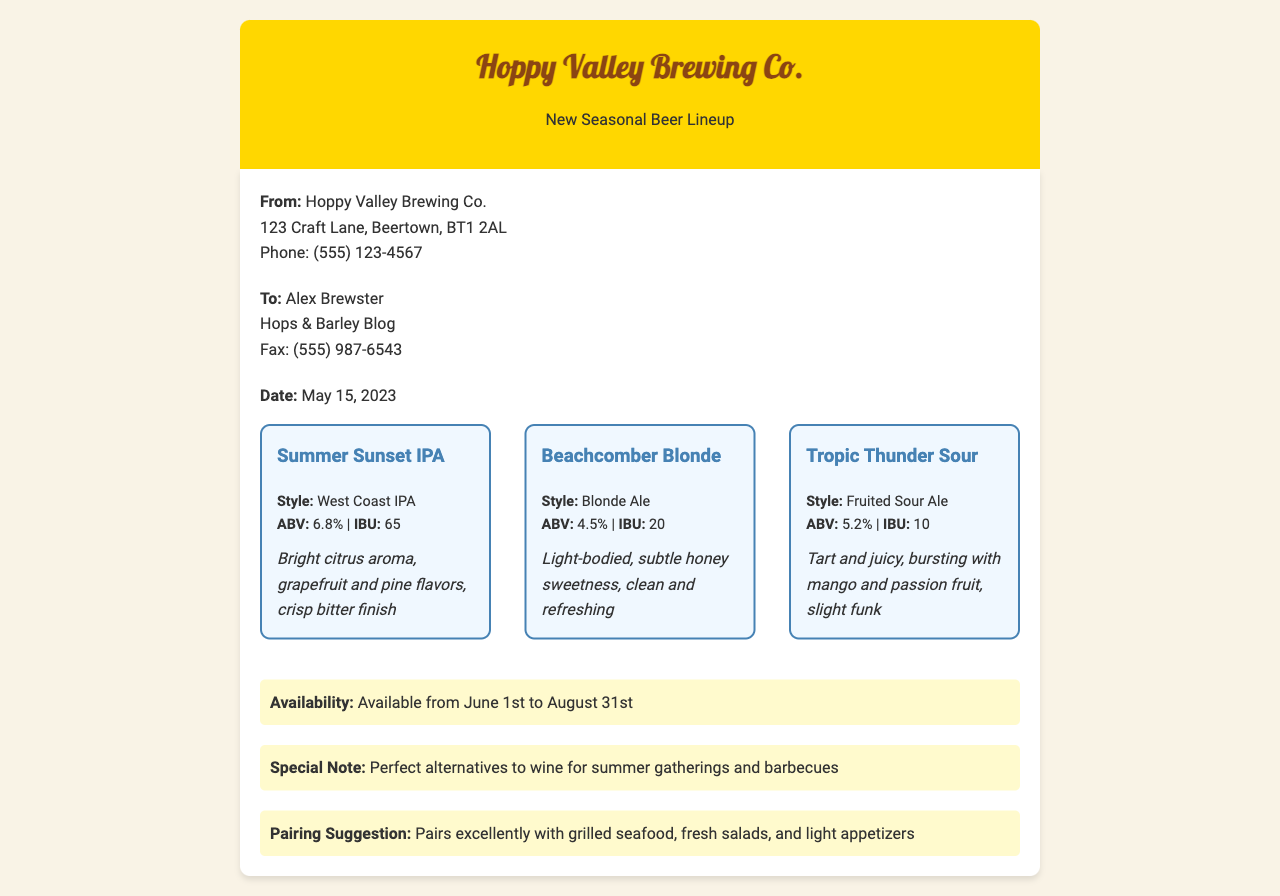what is the name of the brewery? The document clearly states the name of the brewery at the top of the fax.
Answer: Hoppy Valley Brewing Co who is the recipient of the fax? The recipient's name is mentioned just below the sender's information in the fax.
Answer: Alex Brewster what is the date of the fax? The date is provided explicitly in the document, indicating when it was sent.
Answer: May 15, 2023 how many beers are listed in the seasonal lineup? The wine list presents three distinct beers, each described individually in the document.
Answer: 3 what is the ABV of the Beachcomber Blonde? The ABV for Beachcomber Blonde is specified under its beer info section in the document.
Answer: 4.5% what is a pairing suggestion for the beers? The document provides a specific food pairing suggestion towards the end of the content.
Answer: Grilled seafood, fresh salads, and light appetizers what is the availability period for the seasonal beers? The availability of the beers is stated in the document, specifying the time frame.
Answer: June 1st to August 31st what special note is given regarding the beers? A special note is included to highlight their suitability for certain occasions.
Answer: Perfect alternatives to wine for summer gatherings and barbecues 